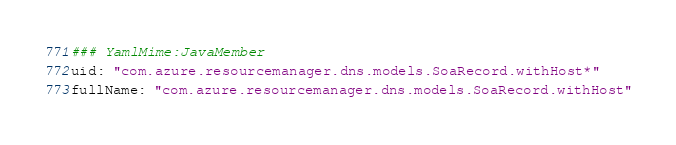Convert code to text. <code><loc_0><loc_0><loc_500><loc_500><_YAML_>### YamlMime:JavaMember
uid: "com.azure.resourcemanager.dns.models.SoaRecord.withHost*"
fullName: "com.azure.resourcemanager.dns.models.SoaRecord.withHost"</code> 